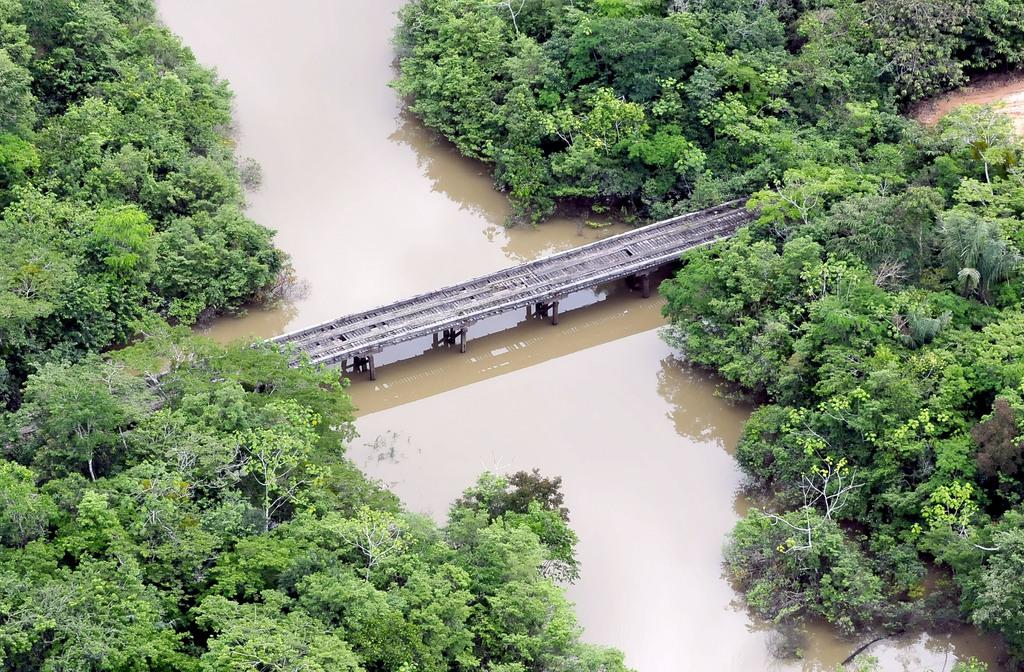What is the main feature of the image? There are a lot of plants in the image. What natural element is present in the image? There is a river in the image. How can people or animals cross the river in the image? A wooden bridge is constructed across the river in the image. What type of knowledge can be gained from the giraffe in the image? There is no giraffe present in the image, so no knowledge can be gained from a giraffe. 